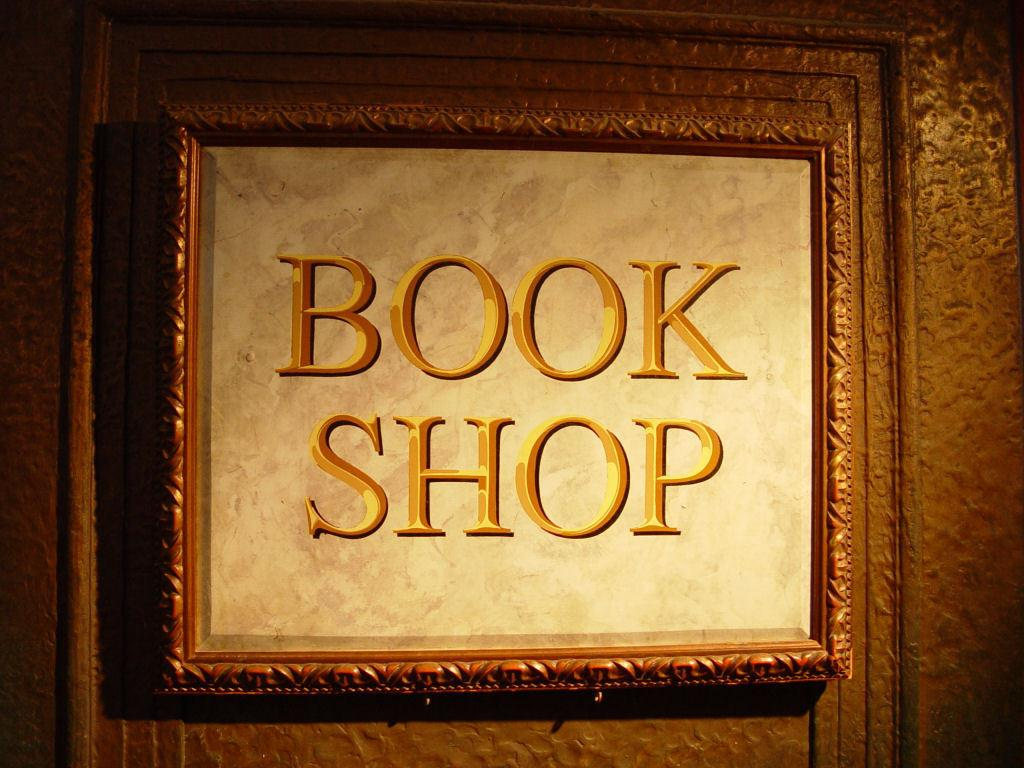<image>
Describe the image concisely. A gold framed picture frame with gold letters that says Book Shop 